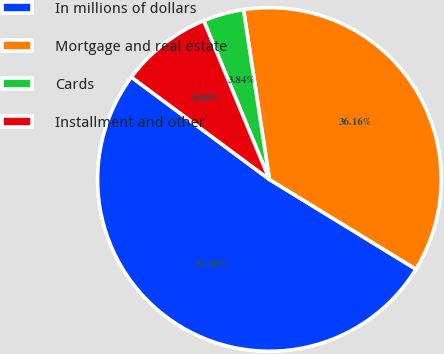Convert chart. <chart><loc_0><loc_0><loc_500><loc_500><pie_chart><fcel>In millions of dollars<fcel>Mortgage and real estate<fcel>Cards<fcel>Installment and other<nl><fcel>51.41%<fcel>36.16%<fcel>3.84%<fcel>8.6%<nl></chart> 